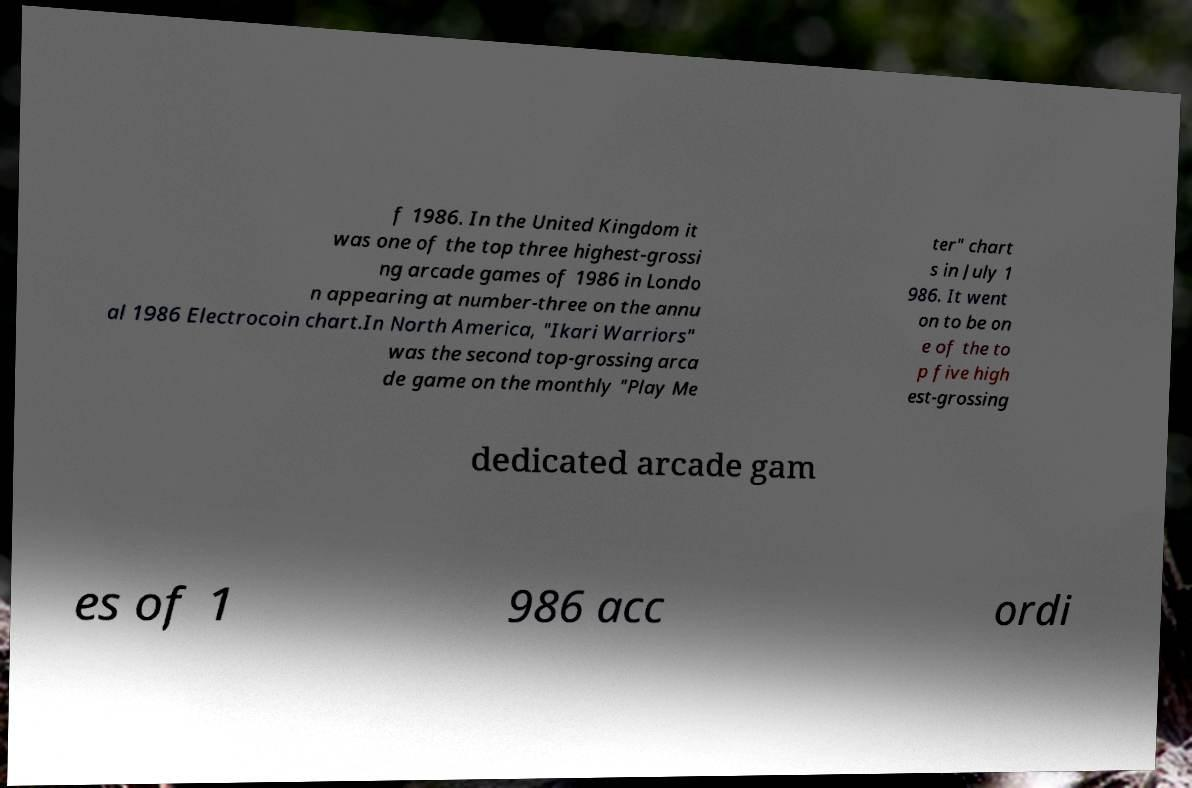Could you extract and type out the text from this image? f 1986. In the United Kingdom it was one of the top three highest-grossi ng arcade games of 1986 in Londo n appearing at number-three on the annu al 1986 Electrocoin chart.In North America, "Ikari Warriors" was the second top-grossing arca de game on the monthly "Play Me ter" chart s in July 1 986. It went on to be on e of the to p five high est-grossing dedicated arcade gam es of 1 986 acc ordi 